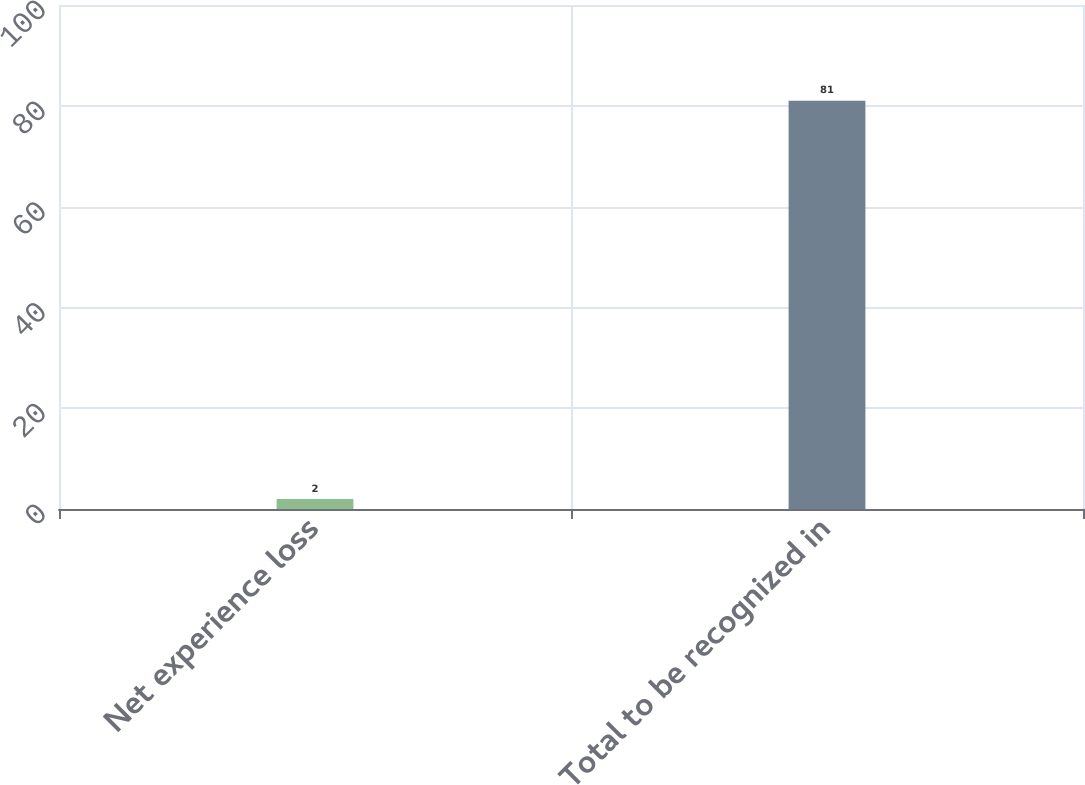<chart> <loc_0><loc_0><loc_500><loc_500><bar_chart><fcel>Net experience loss<fcel>Total to be recognized in<nl><fcel>2<fcel>81<nl></chart> 